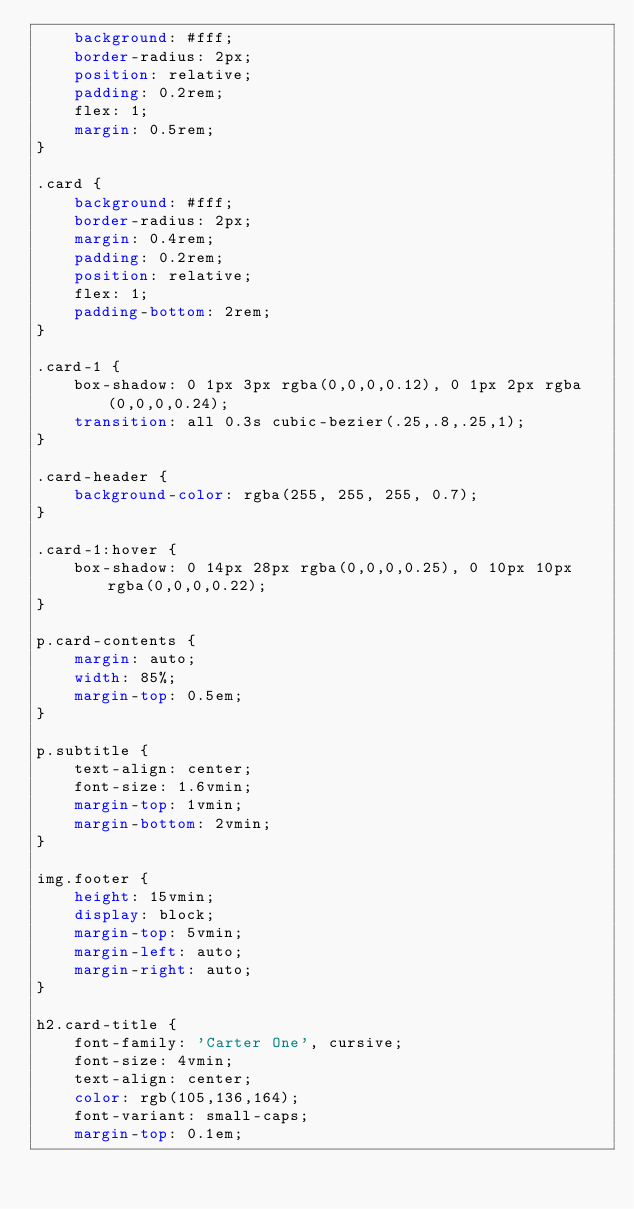Convert code to text. <code><loc_0><loc_0><loc_500><loc_500><_CSS_>    background: #fff;
    border-radius: 2px;
    position: relative;
    padding: 0.2rem;
    flex: 1;
    margin: 0.5rem;
}

.card {
    background: #fff;
    border-radius: 2px;
    margin: 0.4rem;
    padding: 0.2rem;
    position: relative;
    flex: 1;
    padding-bottom: 2rem;
}

.card-1 {
    box-shadow: 0 1px 3px rgba(0,0,0,0.12), 0 1px 2px rgba(0,0,0,0.24);
    transition: all 0.3s cubic-bezier(.25,.8,.25,1);
}

.card-header {
    background-color: rgba(255, 255, 255, 0.7);
}

.card-1:hover {
    box-shadow: 0 14px 28px rgba(0,0,0,0.25), 0 10px 10px rgba(0,0,0,0.22);
}

p.card-contents {
    margin: auto;
    width: 85%;
    margin-top: 0.5em;
}

p.subtitle {
    text-align: center;
    font-size: 1.6vmin;
    margin-top: 1vmin;
    margin-bottom: 2vmin;
}

img.footer {
    height: 15vmin;
    display: block;
    margin-top: 5vmin;
    margin-left: auto;
    margin-right: auto;
}

h2.card-title {
    font-family: 'Carter One', cursive;
    font-size: 4vmin;
    text-align: center;
    color: rgb(105,136,164);
    font-variant: small-caps;
    margin-top: 0.1em;</code> 